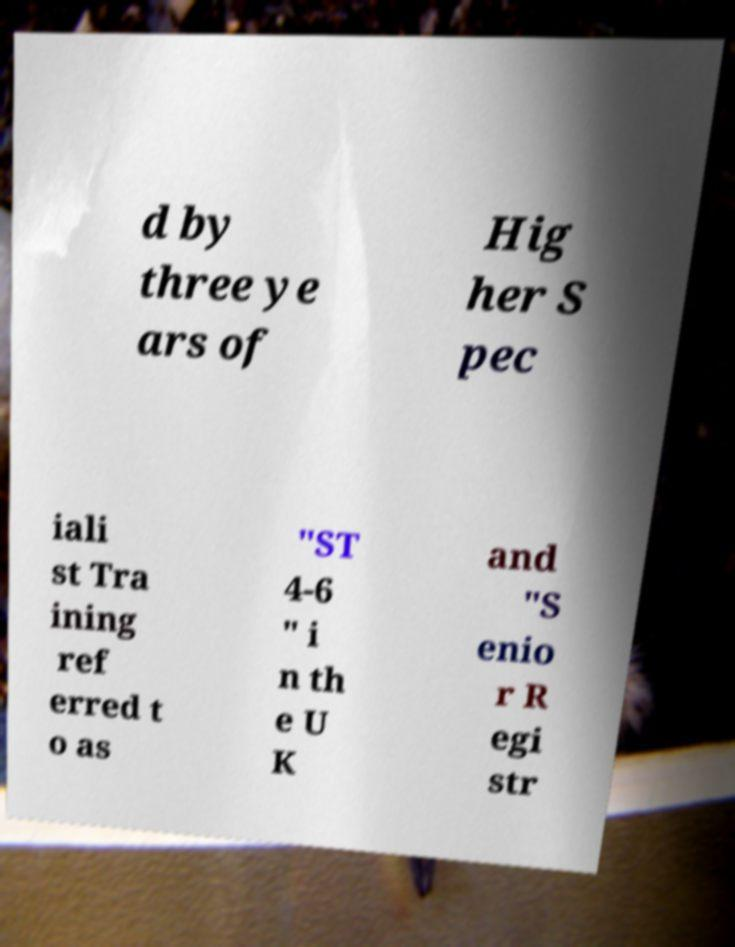Can you accurately transcribe the text from the provided image for me? d by three ye ars of Hig her S pec iali st Tra ining ref erred t o as "ST 4-6 " i n th e U K and "S enio r R egi str 